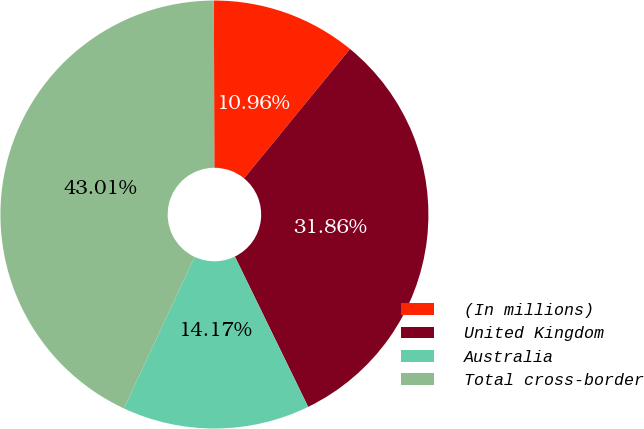Convert chart to OTSL. <chart><loc_0><loc_0><loc_500><loc_500><pie_chart><fcel>(In millions)<fcel>United Kingdom<fcel>Australia<fcel>Total cross-border<nl><fcel>10.96%<fcel>31.86%<fcel>14.17%<fcel>43.01%<nl></chart> 